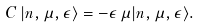<formula> <loc_0><loc_0><loc_500><loc_500>C \, | n , \mu , \epsilon \rangle & = - \epsilon \, \mu | n , \mu , \epsilon \rangle .</formula> 